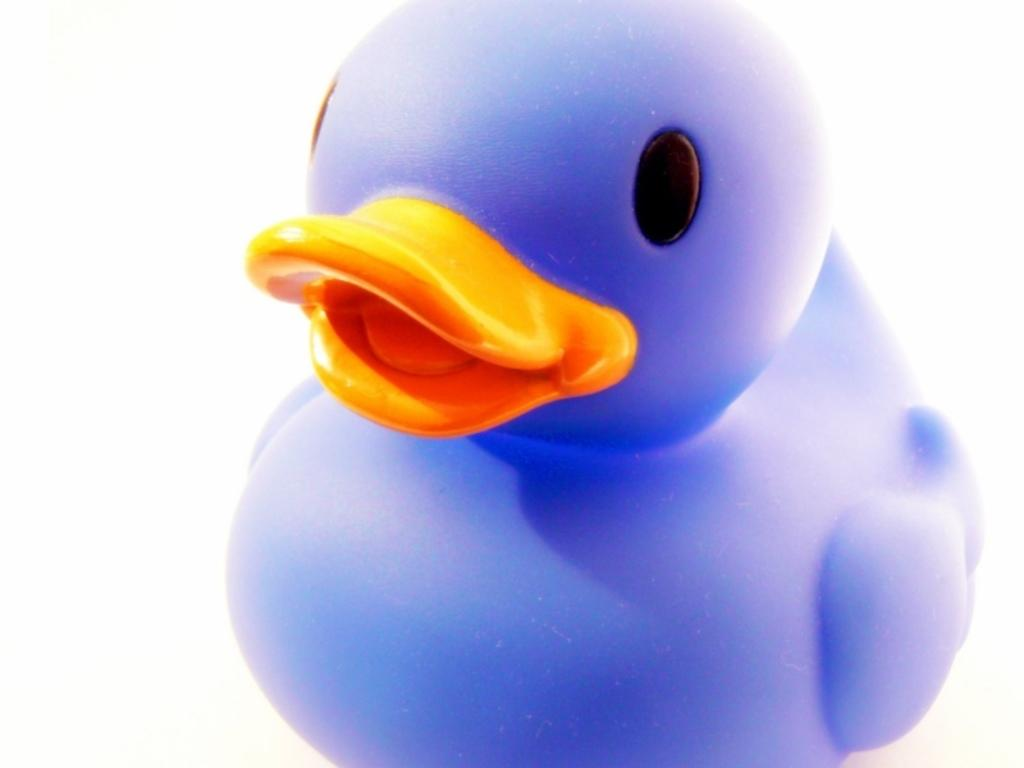What type of toy is present in the image? There is a duck toy in the image. What flavor of cork can be seen in the image? There is no cork or flavor present in the image; it features a duck toy. Is there a volcano visible in the image? No, there is no volcano present in the image; it features a duck toy. 